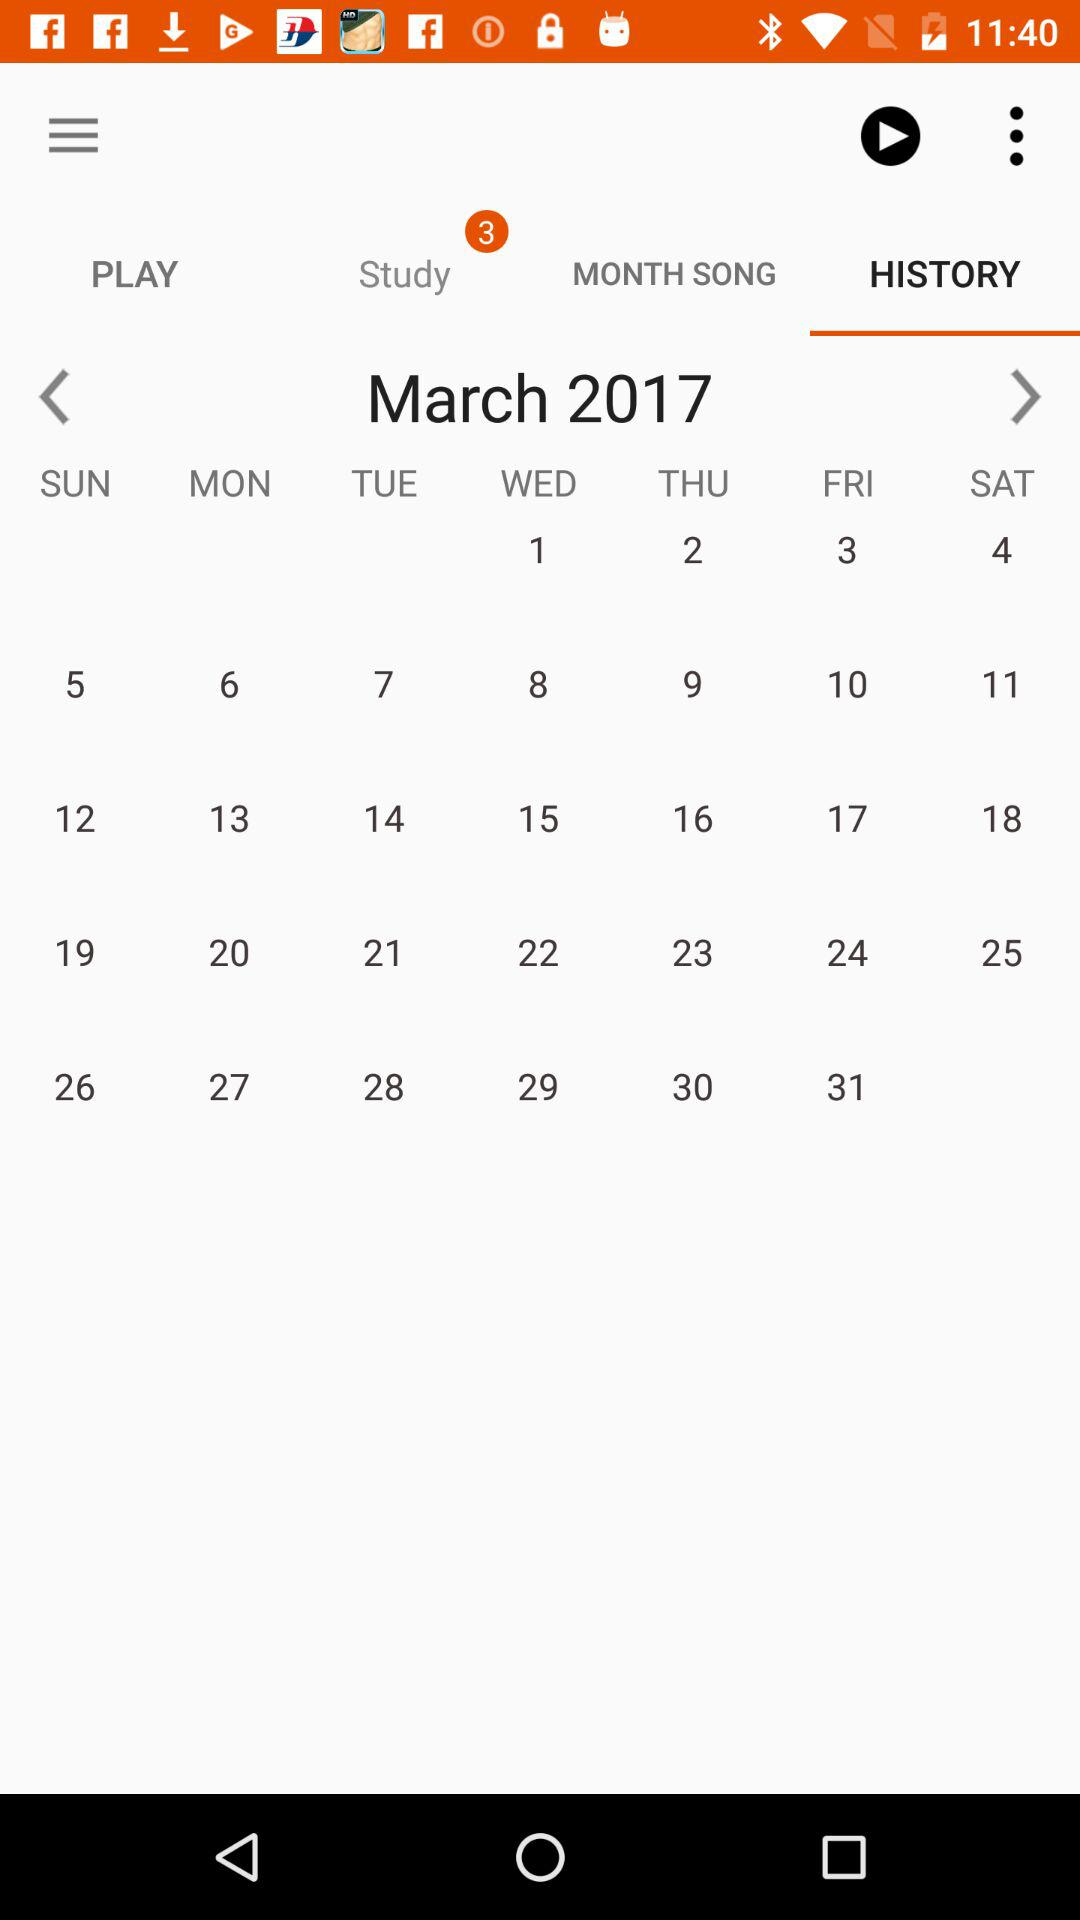What is the day on the 18th of March? The day is Saturday. 